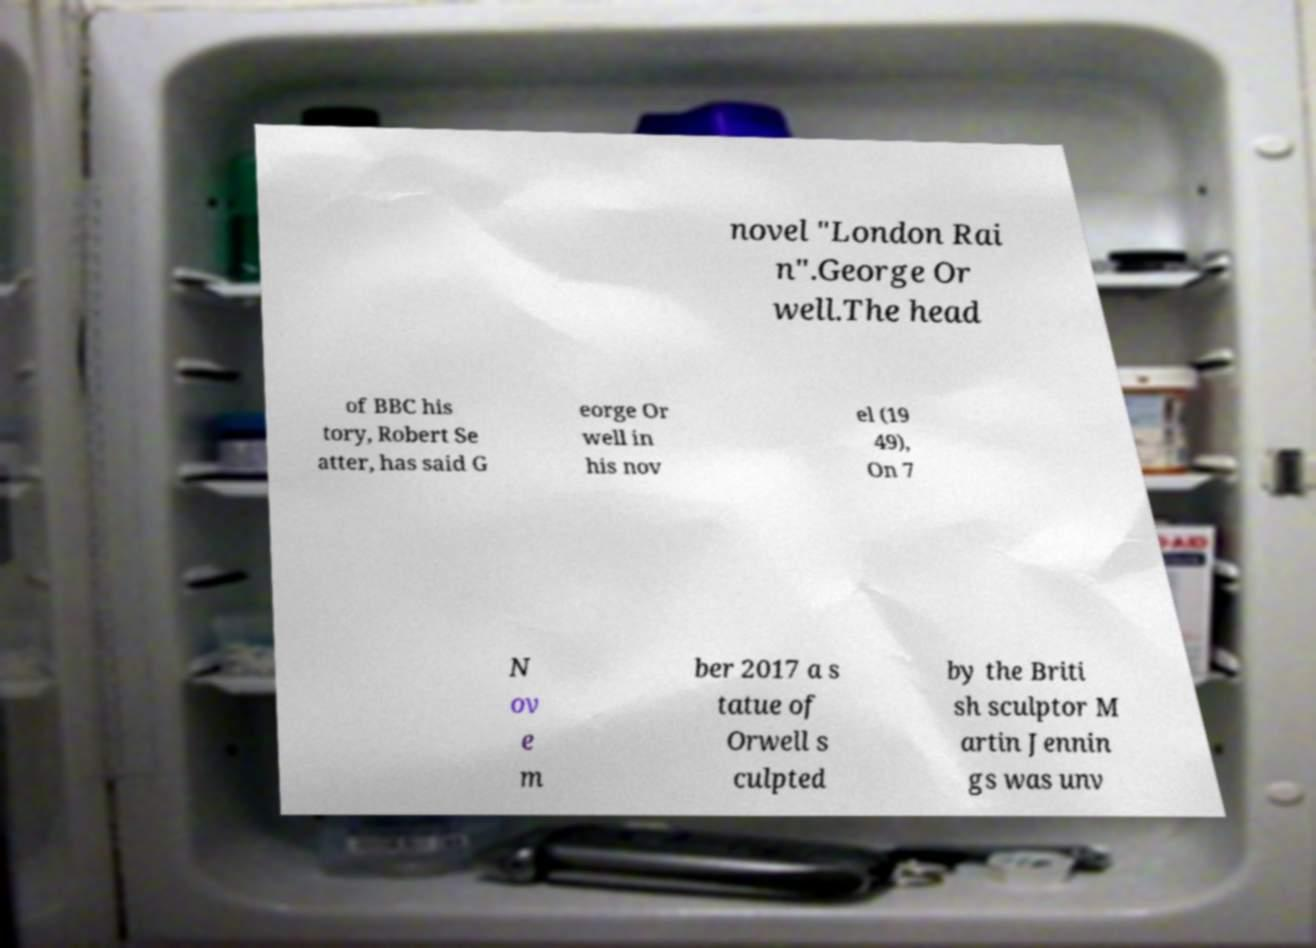Please identify and transcribe the text found in this image. novel "London Rai n".George Or well.The head of BBC his tory, Robert Se atter, has said G eorge Or well in his nov el (19 49), On 7 N ov e m ber 2017 a s tatue of Orwell s culpted by the Briti sh sculptor M artin Jennin gs was unv 